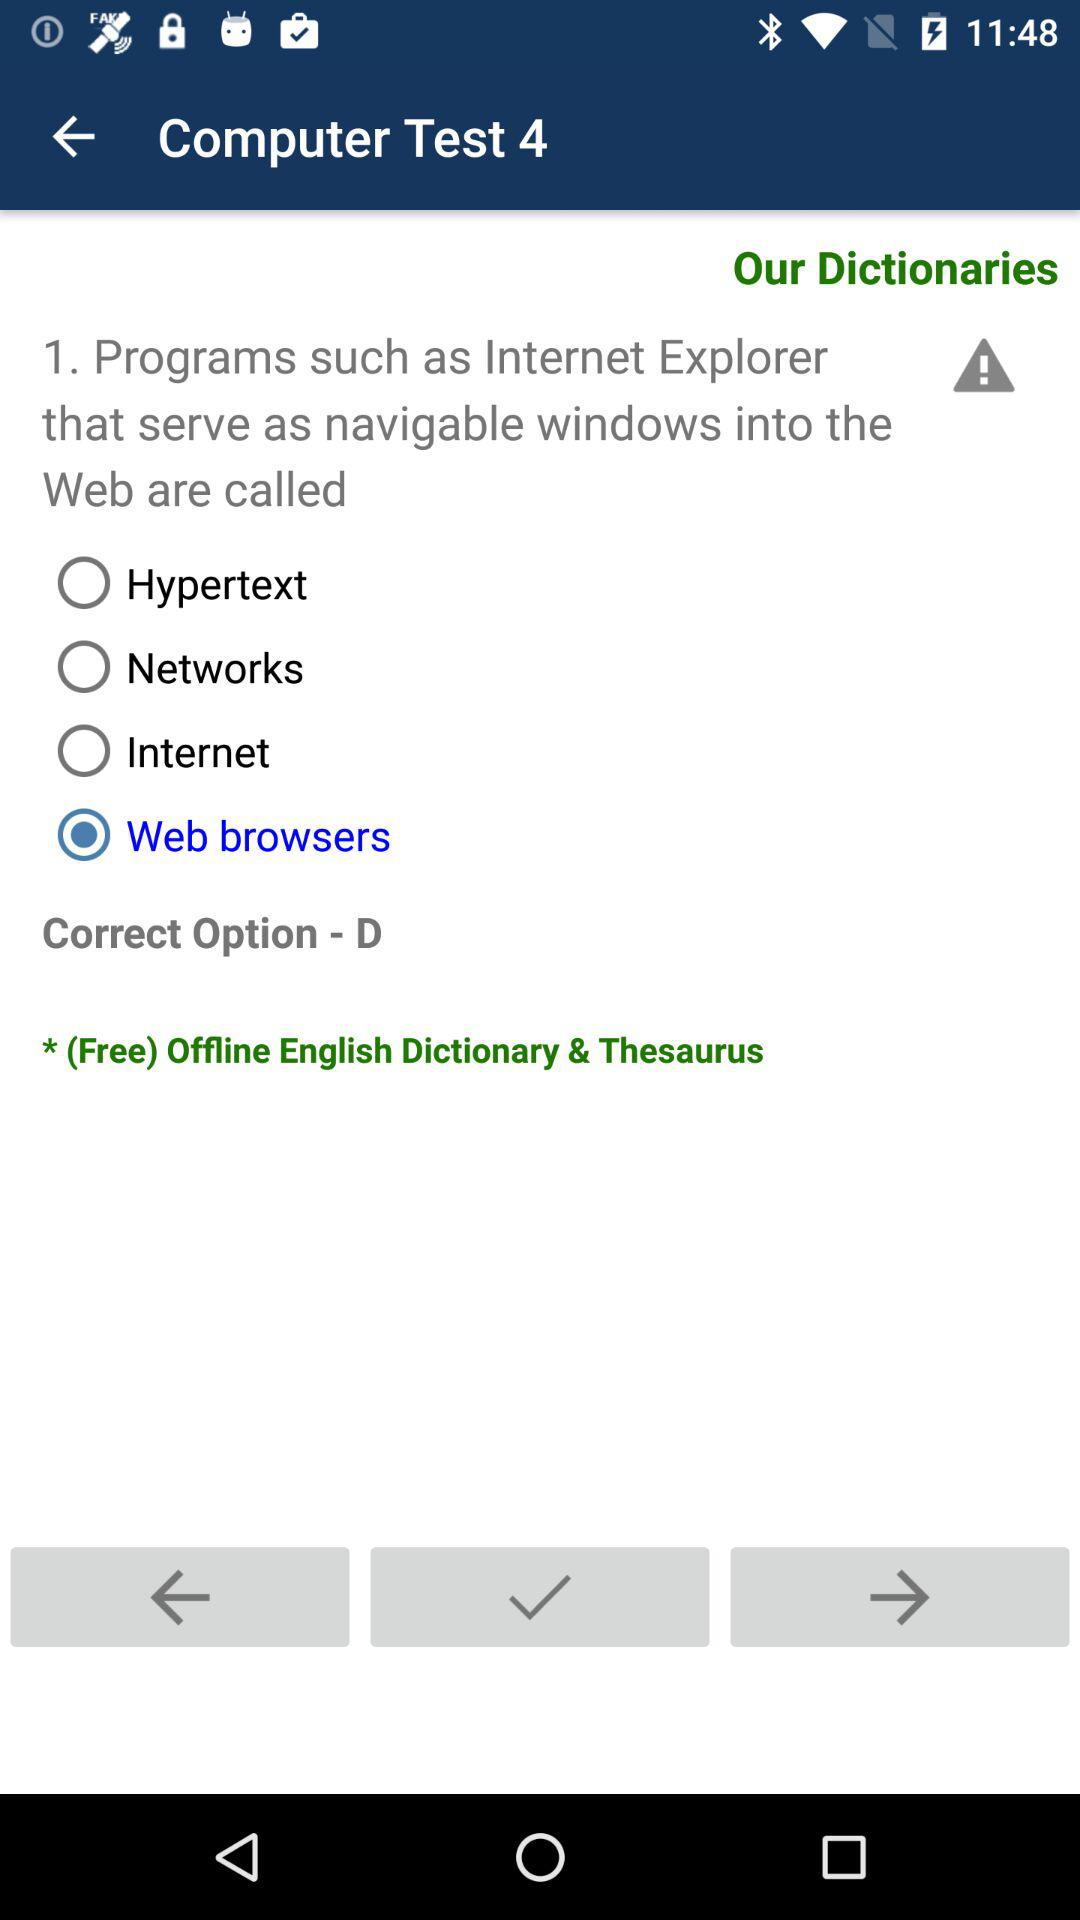What is the selected option? The selected option is "Web browsers". 